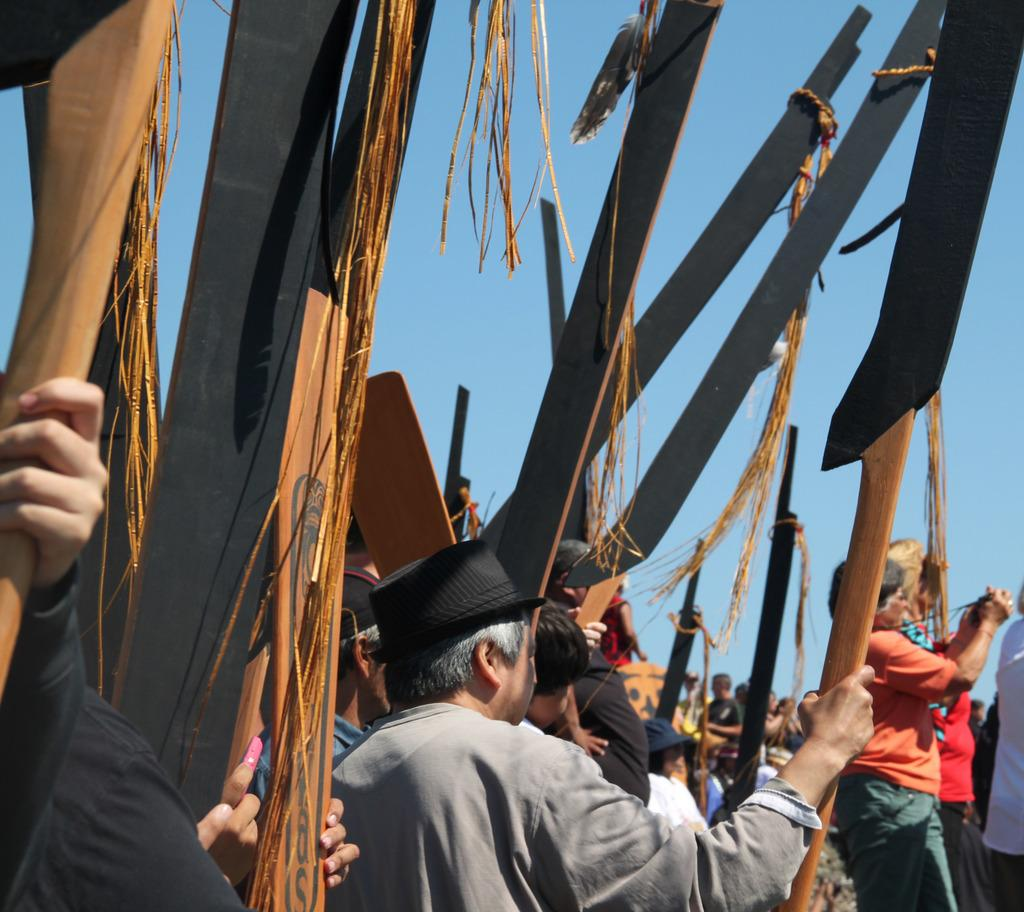What is happening in the image? There are people standing in the image. What are the people holding in their hands? The people are holding wooden objects. What can be seen in the distance in the image? The sky is visible in the background of the image. What type of power source is being used by the people in the image? There is no indication of a power source in the image; the people are simply holding wooden objects. 